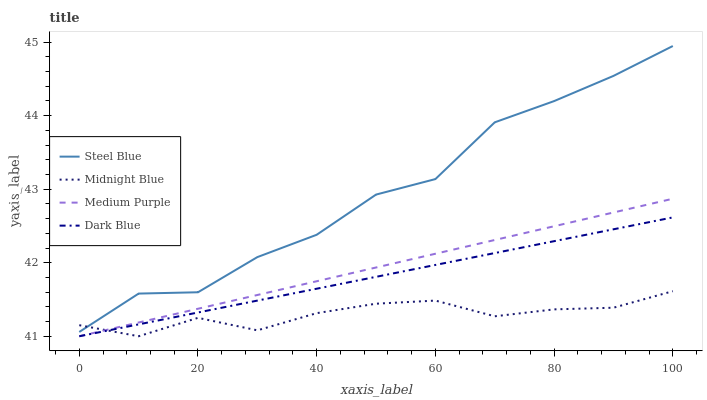Does Midnight Blue have the minimum area under the curve?
Answer yes or no. Yes. Does Steel Blue have the maximum area under the curve?
Answer yes or no. Yes. Does Dark Blue have the minimum area under the curve?
Answer yes or no. No. Does Dark Blue have the maximum area under the curve?
Answer yes or no. No. Is Medium Purple the smoothest?
Answer yes or no. Yes. Is Steel Blue the roughest?
Answer yes or no. Yes. Is Dark Blue the smoothest?
Answer yes or no. No. Is Dark Blue the roughest?
Answer yes or no. No. Does Steel Blue have the lowest value?
Answer yes or no. No. Does Dark Blue have the highest value?
Answer yes or no. No. Is Medium Purple less than Steel Blue?
Answer yes or no. Yes. Is Steel Blue greater than Medium Purple?
Answer yes or no. Yes. Does Medium Purple intersect Steel Blue?
Answer yes or no. No. 